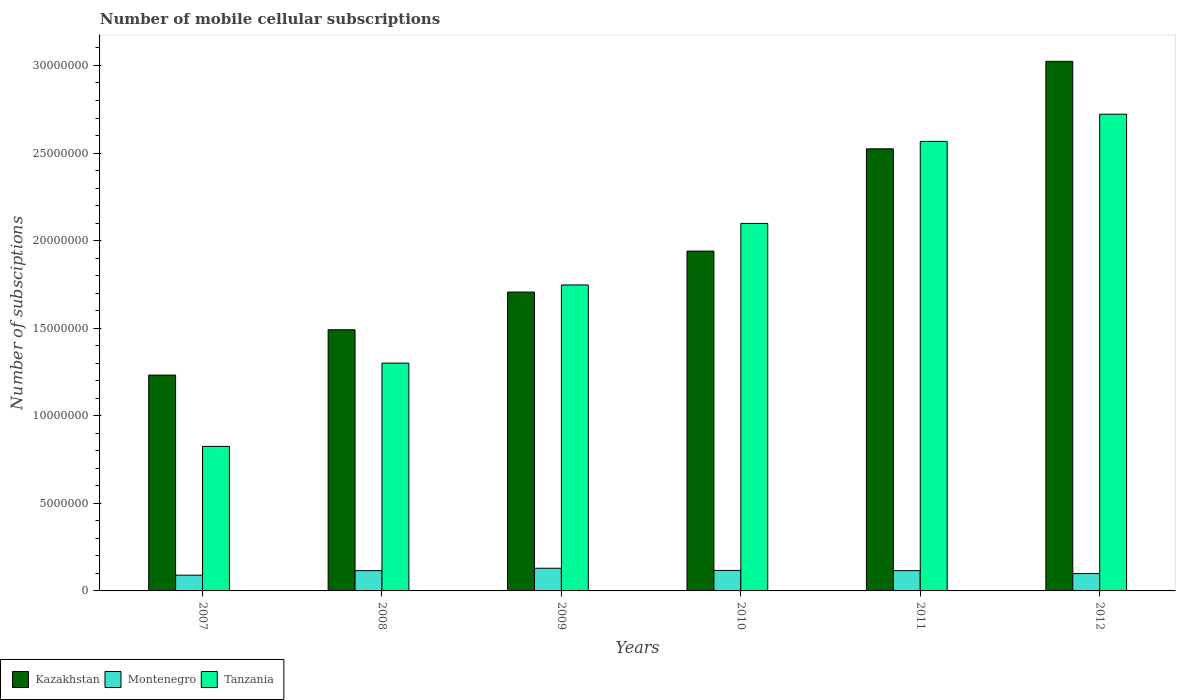How many different coloured bars are there?
Give a very brief answer. 3. How many bars are there on the 1st tick from the left?
Keep it short and to the point. 3. What is the label of the 1st group of bars from the left?
Your answer should be compact. 2007. In how many cases, is the number of bars for a given year not equal to the number of legend labels?
Offer a terse response. 0. What is the number of mobile cellular subscriptions in Tanzania in 2011?
Provide a short and direct response. 2.57e+07. Across all years, what is the maximum number of mobile cellular subscriptions in Tanzania?
Keep it short and to the point. 2.72e+07. Across all years, what is the minimum number of mobile cellular subscriptions in Tanzania?
Your answer should be very brief. 8.25e+06. In which year was the number of mobile cellular subscriptions in Montenegro maximum?
Provide a succinct answer. 2009. In which year was the number of mobile cellular subscriptions in Montenegro minimum?
Give a very brief answer. 2007. What is the total number of mobile cellular subscriptions in Tanzania in the graph?
Offer a very short reply. 1.13e+08. What is the difference between the number of mobile cellular subscriptions in Tanzania in 2010 and that in 2011?
Offer a terse response. -4.68e+06. What is the difference between the number of mobile cellular subscriptions in Montenegro in 2007 and the number of mobile cellular subscriptions in Tanzania in 2010?
Give a very brief answer. -2.01e+07. What is the average number of mobile cellular subscriptions in Kazakhstan per year?
Offer a terse response. 1.99e+07. In the year 2012, what is the difference between the number of mobile cellular subscriptions in Montenegro and number of mobile cellular subscriptions in Tanzania?
Ensure brevity in your answer.  -2.62e+07. In how many years, is the number of mobile cellular subscriptions in Tanzania greater than 18000000?
Offer a terse response. 3. What is the ratio of the number of mobile cellular subscriptions in Tanzania in 2009 to that in 2011?
Your response must be concise. 0.68. Is the number of mobile cellular subscriptions in Kazakhstan in 2008 less than that in 2010?
Offer a terse response. Yes. What is the difference between the highest and the second highest number of mobile cellular subscriptions in Tanzania?
Your answer should be very brief. 1.55e+06. What is the difference between the highest and the lowest number of mobile cellular subscriptions in Tanzania?
Make the answer very short. 1.90e+07. Is the sum of the number of mobile cellular subscriptions in Montenegro in 2011 and 2012 greater than the maximum number of mobile cellular subscriptions in Tanzania across all years?
Provide a short and direct response. No. What does the 3rd bar from the left in 2010 represents?
Offer a terse response. Tanzania. What does the 3rd bar from the right in 2009 represents?
Provide a succinct answer. Kazakhstan. How many bars are there?
Your response must be concise. 18. How many years are there in the graph?
Your response must be concise. 6. What is the difference between two consecutive major ticks on the Y-axis?
Make the answer very short. 5.00e+06. Are the values on the major ticks of Y-axis written in scientific E-notation?
Keep it short and to the point. No. Does the graph contain grids?
Provide a short and direct response. No. How many legend labels are there?
Your answer should be very brief. 3. How are the legend labels stacked?
Provide a succinct answer. Horizontal. What is the title of the graph?
Offer a terse response. Number of mobile cellular subscriptions. Does "Marshall Islands" appear as one of the legend labels in the graph?
Your answer should be compact. No. What is the label or title of the Y-axis?
Your answer should be very brief. Number of subsciptions. What is the Number of subsciptions of Kazakhstan in 2007?
Offer a very short reply. 1.23e+07. What is the Number of subsciptions in Montenegro in 2007?
Offer a very short reply. 9.00e+05. What is the Number of subsciptions in Tanzania in 2007?
Give a very brief answer. 8.25e+06. What is the Number of subsciptions of Kazakhstan in 2008?
Your response must be concise. 1.49e+07. What is the Number of subsciptions of Montenegro in 2008?
Provide a succinct answer. 1.16e+06. What is the Number of subsciptions of Tanzania in 2008?
Your response must be concise. 1.30e+07. What is the Number of subsciptions in Kazakhstan in 2009?
Give a very brief answer. 1.71e+07. What is the Number of subsciptions in Montenegro in 2009?
Offer a terse response. 1.29e+06. What is the Number of subsciptions in Tanzania in 2009?
Make the answer very short. 1.75e+07. What is the Number of subsciptions of Kazakhstan in 2010?
Make the answer very short. 1.94e+07. What is the Number of subsciptions in Montenegro in 2010?
Your response must be concise. 1.17e+06. What is the Number of subsciptions in Tanzania in 2010?
Your answer should be very brief. 2.10e+07. What is the Number of subsciptions of Kazakhstan in 2011?
Offer a terse response. 2.52e+07. What is the Number of subsciptions of Montenegro in 2011?
Your answer should be very brief. 1.16e+06. What is the Number of subsciptions of Tanzania in 2011?
Provide a succinct answer. 2.57e+07. What is the Number of subsciptions of Kazakhstan in 2012?
Your answer should be compact. 3.02e+07. What is the Number of subsciptions of Montenegro in 2012?
Offer a terse response. 9.91e+05. What is the Number of subsciptions in Tanzania in 2012?
Ensure brevity in your answer.  2.72e+07. Across all years, what is the maximum Number of subsciptions of Kazakhstan?
Ensure brevity in your answer.  3.02e+07. Across all years, what is the maximum Number of subsciptions of Montenegro?
Offer a very short reply. 1.29e+06. Across all years, what is the maximum Number of subsciptions of Tanzania?
Provide a short and direct response. 2.72e+07. Across all years, what is the minimum Number of subsciptions of Kazakhstan?
Ensure brevity in your answer.  1.23e+07. Across all years, what is the minimum Number of subsciptions of Tanzania?
Your response must be concise. 8.25e+06. What is the total Number of subsciptions in Kazakhstan in the graph?
Give a very brief answer. 1.19e+08. What is the total Number of subsciptions of Montenegro in the graph?
Provide a short and direct response. 6.67e+06. What is the total Number of subsciptions in Tanzania in the graph?
Give a very brief answer. 1.13e+08. What is the difference between the Number of subsciptions in Kazakhstan in 2007 and that in 2008?
Keep it short and to the point. -2.59e+06. What is the difference between the Number of subsciptions in Montenegro in 2007 and that in 2008?
Your answer should be compact. -2.58e+05. What is the difference between the Number of subsciptions in Tanzania in 2007 and that in 2008?
Keep it short and to the point. -4.75e+06. What is the difference between the Number of subsciptions of Kazakhstan in 2007 and that in 2009?
Provide a short and direct response. -4.74e+06. What is the difference between the Number of subsciptions in Montenegro in 2007 and that in 2009?
Your answer should be compact. -3.94e+05. What is the difference between the Number of subsciptions in Tanzania in 2007 and that in 2009?
Offer a very short reply. -9.22e+06. What is the difference between the Number of subsciptions in Kazakhstan in 2007 and that in 2010?
Your answer should be compact. -7.08e+06. What is the difference between the Number of subsciptions of Montenegro in 2007 and that in 2010?
Give a very brief answer. -2.70e+05. What is the difference between the Number of subsciptions in Tanzania in 2007 and that in 2010?
Your answer should be very brief. -1.27e+07. What is the difference between the Number of subsciptions of Kazakhstan in 2007 and that in 2011?
Provide a succinct answer. -1.29e+07. What is the difference between the Number of subsciptions of Montenegro in 2007 and that in 2011?
Provide a succinct answer. -2.59e+05. What is the difference between the Number of subsciptions in Tanzania in 2007 and that in 2011?
Offer a terse response. -1.74e+07. What is the difference between the Number of subsciptions in Kazakhstan in 2007 and that in 2012?
Give a very brief answer. -1.79e+07. What is the difference between the Number of subsciptions of Montenegro in 2007 and that in 2012?
Your answer should be very brief. -9.09e+04. What is the difference between the Number of subsciptions in Tanzania in 2007 and that in 2012?
Provide a succinct answer. -1.90e+07. What is the difference between the Number of subsciptions in Kazakhstan in 2008 and that in 2009?
Your answer should be compact. -2.15e+06. What is the difference between the Number of subsciptions in Montenegro in 2008 and that in 2009?
Your response must be concise. -1.36e+05. What is the difference between the Number of subsciptions in Tanzania in 2008 and that in 2009?
Offer a terse response. -4.46e+06. What is the difference between the Number of subsciptions of Kazakhstan in 2008 and that in 2010?
Your answer should be compact. -4.49e+06. What is the difference between the Number of subsciptions of Montenegro in 2008 and that in 2010?
Your answer should be compact. -1.20e+04. What is the difference between the Number of subsciptions of Tanzania in 2008 and that in 2010?
Offer a terse response. -7.98e+06. What is the difference between the Number of subsciptions of Kazakhstan in 2008 and that in 2011?
Provide a short and direct response. -1.03e+07. What is the difference between the Number of subsciptions of Montenegro in 2008 and that in 2011?
Ensure brevity in your answer.  -1080. What is the difference between the Number of subsciptions of Tanzania in 2008 and that in 2011?
Offer a very short reply. -1.27e+07. What is the difference between the Number of subsciptions in Kazakhstan in 2008 and that in 2012?
Ensure brevity in your answer.  -1.53e+07. What is the difference between the Number of subsciptions in Montenegro in 2008 and that in 2012?
Your answer should be compact. 1.67e+05. What is the difference between the Number of subsciptions in Tanzania in 2008 and that in 2012?
Ensure brevity in your answer.  -1.42e+07. What is the difference between the Number of subsciptions of Kazakhstan in 2009 and that in 2010?
Your answer should be compact. -2.34e+06. What is the difference between the Number of subsciptions of Montenegro in 2009 and that in 2010?
Provide a succinct answer. 1.24e+05. What is the difference between the Number of subsciptions of Tanzania in 2009 and that in 2010?
Your answer should be compact. -3.51e+06. What is the difference between the Number of subsciptions in Kazakhstan in 2009 and that in 2011?
Your answer should be very brief. -8.18e+06. What is the difference between the Number of subsciptions of Montenegro in 2009 and that in 2011?
Provide a short and direct response. 1.35e+05. What is the difference between the Number of subsciptions of Tanzania in 2009 and that in 2011?
Your response must be concise. -8.20e+06. What is the difference between the Number of subsciptions in Kazakhstan in 2009 and that in 2012?
Your response must be concise. -1.32e+07. What is the difference between the Number of subsciptions in Montenegro in 2009 and that in 2012?
Offer a very short reply. 3.03e+05. What is the difference between the Number of subsciptions of Tanzania in 2009 and that in 2012?
Ensure brevity in your answer.  -9.75e+06. What is the difference between the Number of subsciptions in Kazakhstan in 2010 and that in 2011?
Give a very brief answer. -5.84e+06. What is the difference between the Number of subsciptions in Montenegro in 2010 and that in 2011?
Make the answer very short. 1.09e+04. What is the difference between the Number of subsciptions of Tanzania in 2010 and that in 2011?
Offer a very short reply. -4.68e+06. What is the difference between the Number of subsciptions of Kazakhstan in 2010 and that in 2012?
Keep it short and to the point. -1.08e+07. What is the difference between the Number of subsciptions in Montenegro in 2010 and that in 2012?
Keep it short and to the point. 1.79e+05. What is the difference between the Number of subsciptions in Tanzania in 2010 and that in 2012?
Give a very brief answer. -6.24e+06. What is the difference between the Number of subsciptions in Kazakhstan in 2011 and that in 2012?
Provide a short and direct response. -4.99e+06. What is the difference between the Number of subsciptions in Montenegro in 2011 and that in 2012?
Your response must be concise. 1.68e+05. What is the difference between the Number of subsciptions in Tanzania in 2011 and that in 2012?
Provide a short and direct response. -1.55e+06. What is the difference between the Number of subsciptions of Kazakhstan in 2007 and the Number of subsciptions of Montenegro in 2008?
Keep it short and to the point. 1.12e+07. What is the difference between the Number of subsciptions of Kazakhstan in 2007 and the Number of subsciptions of Tanzania in 2008?
Offer a terse response. -6.84e+05. What is the difference between the Number of subsciptions of Montenegro in 2007 and the Number of subsciptions of Tanzania in 2008?
Offer a very short reply. -1.21e+07. What is the difference between the Number of subsciptions of Kazakhstan in 2007 and the Number of subsciptions of Montenegro in 2009?
Your answer should be compact. 1.10e+07. What is the difference between the Number of subsciptions in Kazakhstan in 2007 and the Number of subsciptions in Tanzania in 2009?
Offer a very short reply. -5.15e+06. What is the difference between the Number of subsciptions in Montenegro in 2007 and the Number of subsciptions in Tanzania in 2009?
Offer a very short reply. -1.66e+07. What is the difference between the Number of subsciptions of Kazakhstan in 2007 and the Number of subsciptions of Montenegro in 2010?
Make the answer very short. 1.12e+07. What is the difference between the Number of subsciptions of Kazakhstan in 2007 and the Number of subsciptions of Tanzania in 2010?
Your answer should be very brief. -8.66e+06. What is the difference between the Number of subsciptions of Montenegro in 2007 and the Number of subsciptions of Tanzania in 2010?
Make the answer very short. -2.01e+07. What is the difference between the Number of subsciptions of Kazakhstan in 2007 and the Number of subsciptions of Montenegro in 2011?
Your response must be concise. 1.12e+07. What is the difference between the Number of subsciptions in Kazakhstan in 2007 and the Number of subsciptions in Tanzania in 2011?
Offer a terse response. -1.33e+07. What is the difference between the Number of subsciptions in Montenegro in 2007 and the Number of subsciptions in Tanzania in 2011?
Your answer should be very brief. -2.48e+07. What is the difference between the Number of subsciptions of Kazakhstan in 2007 and the Number of subsciptions of Montenegro in 2012?
Give a very brief answer. 1.13e+07. What is the difference between the Number of subsciptions of Kazakhstan in 2007 and the Number of subsciptions of Tanzania in 2012?
Your answer should be very brief. -1.49e+07. What is the difference between the Number of subsciptions in Montenegro in 2007 and the Number of subsciptions in Tanzania in 2012?
Ensure brevity in your answer.  -2.63e+07. What is the difference between the Number of subsciptions in Kazakhstan in 2008 and the Number of subsciptions in Montenegro in 2009?
Provide a short and direct response. 1.36e+07. What is the difference between the Number of subsciptions in Kazakhstan in 2008 and the Number of subsciptions in Tanzania in 2009?
Make the answer very short. -2.56e+06. What is the difference between the Number of subsciptions in Montenegro in 2008 and the Number of subsciptions in Tanzania in 2009?
Ensure brevity in your answer.  -1.63e+07. What is the difference between the Number of subsciptions in Kazakhstan in 2008 and the Number of subsciptions in Montenegro in 2010?
Your answer should be compact. 1.37e+07. What is the difference between the Number of subsciptions in Kazakhstan in 2008 and the Number of subsciptions in Tanzania in 2010?
Offer a very short reply. -6.07e+06. What is the difference between the Number of subsciptions of Montenegro in 2008 and the Number of subsciptions of Tanzania in 2010?
Your answer should be compact. -1.98e+07. What is the difference between the Number of subsciptions of Kazakhstan in 2008 and the Number of subsciptions of Montenegro in 2011?
Your answer should be very brief. 1.38e+07. What is the difference between the Number of subsciptions in Kazakhstan in 2008 and the Number of subsciptions in Tanzania in 2011?
Offer a terse response. -1.08e+07. What is the difference between the Number of subsciptions of Montenegro in 2008 and the Number of subsciptions of Tanzania in 2011?
Keep it short and to the point. -2.45e+07. What is the difference between the Number of subsciptions in Kazakhstan in 2008 and the Number of subsciptions in Montenegro in 2012?
Your answer should be compact. 1.39e+07. What is the difference between the Number of subsciptions in Kazakhstan in 2008 and the Number of subsciptions in Tanzania in 2012?
Keep it short and to the point. -1.23e+07. What is the difference between the Number of subsciptions in Montenegro in 2008 and the Number of subsciptions in Tanzania in 2012?
Your response must be concise. -2.61e+07. What is the difference between the Number of subsciptions of Kazakhstan in 2009 and the Number of subsciptions of Montenegro in 2010?
Offer a terse response. 1.59e+07. What is the difference between the Number of subsciptions of Kazakhstan in 2009 and the Number of subsciptions of Tanzania in 2010?
Give a very brief answer. -3.92e+06. What is the difference between the Number of subsciptions of Montenegro in 2009 and the Number of subsciptions of Tanzania in 2010?
Keep it short and to the point. -1.97e+07. What is the difference between the Number of subsciptions of Kazakhstan in 2009 and the Number of subsciptions of Montenegro in 2011?
Give a very brief answer. 1.59e+07. What is the difference between the Number of subsciptions of Kazakhstan in 2009 and the Number of subsciptions of Tanzania in 2011?
Your answer should be compact. -8.60e+06. What is the difference between the Number of subsciptions of Montenegro in 2009 and the Number of subsciptions of Tanzania in 2011?
Your response must be concise. -2.44e+07. What is the difference between the Number of subsciptions of Kazakhstan in 2009 and the Number of subsciptions of Montenegro in 2012?
Offer a terse response. 1.61e+07. What is the difference between the Number of subsciptions in Kazakhstan in 2009 and the Number of subsciptions in Tanzania in 2012?
Your answer should be very brief. -1.02e+07. What is the difference between the Number of subsciptions of Montenegro in 2009 and the Number of subsciptions of Tanzania in 2012?
Ensure brevity in your answer.  -2.59e+07. What is the difference between the Number of subsciptions of Kazakhstan in 2010 and the Number of subsciptions of Montenegro in 2011?
Your answer should be compact. 1.82e+07. What is the difference between the Number of subsciptions in Kazakhstan in 2010 and the Number of subsciptions in Tanzania in 2011?
Offer a very short reply. -6.26e+06. What is the difference between the Number of subsciptions of Montenegro in 2010 and the Number of subsciptions of Tanzania in 2011?
Your answer should be very brief. -2.45e+07. What is the difference between the Number of subsciptions in Kazakhstan in 2010 and the Number of subsciptions in Montenegro in 2012?
Your response must be concise. 1.84e+07. What is the difference between the Number of subsciptions in Kazakhstan in 2010 and the Number of subsciptions in Tanzania in 2012?
Your response must be concise. -7.82e+06. What is the difference between the Number of subsciptions in Montenegro in 2010 and the Number of subsciptions in Tanzania in 2012?
Offer a very short reply. -2.60e+07. What is the difference between the Number of subsciptions of Kazakhstan in 2011 and the Number of subsciptions of Montenegro in 2012?
Offer a terse response. 2.42e+07. What is the difference between the Number of subsciptions of Kazakhstan in 2011 and the Number of subsciptions of Tanzania in 2012?
Offer a terse response. -1.98e+06. What is the difference between the Number of subsciptions in Montenegro in 2011 and the Number of subsciptions in Tanzania in 2012?
Give a very brief answer. -2.61e+07. What is the average Number of subsciptions of Kazakhstan per year?
Provide a succinct answer. 1.99e+07. What is the average Number of subsciptions in Montenegro per year?
Make the answer very short. 1.11e+06. What is the average Number of subsciptions in Tanzania per year?
Give a very brief answer. 1.88e+07. In the year 2007, what is the difference between the Number of subsciptions in Kazakhstan and Number of subsciptions in Montenegro?
Your response must be concise. 1.14e+07. In the year 2007, what is the difference between the Number of subsciptions of Kazakhstan and Number of subsciptions of Tanzania?
Offer a terse response. 4.07e+06. In the year 2007, what is the difference between the Number of subsciptions of Montenegro and Number of subsciptions of Tanzania?
Your answer should be compact. -7.35e+06. In the year 2008, what is the difference between the Number of subsciptions of Kazakhstan and Number of subsciptions of Montenegro?
Offer a terse response. 1.38e+07. In the year 2008, what is the difference between the Number of subsciptions of Kazakhstan and Number of subsciptions of Tanzania?
Your answer should be very brief. 1.90e+06. In the year 2008, what is the difference between the Number of subsciptions in Montenegro and Number of subsciptions in Tanzania?
Your response must be concise. -1.18e+07. In the year 2009, what is the difference between the Number of subsciptions in Kazakhstan and Number of subsciptions in Montenegro?
Make the answer very short. 1.58e+07. In the year 2009, what is the difference between the Number of subsciptions in Kazakhstan and Number of subsciptions in Tanzania?
Your answer should be compact. -4.06e+05. In the year 2009, what is the difference between the Number of subsciptions in Montenegro and Number of subsciptions in Tanzania?
Your answer should be compact. -1.62e+07. In the year 2010, what is the difference between the Number of subsciptions of Kazakhstan and Number of subsciptions of Montenegro?
Provide a short and direct response. 1.82e+07. In the year 2010, what is the difference between the Number of subsciptions in Kazakhstan and Number of subsciptions in Tanzania?
Provide a short and direct response. -1.58e+06. In the year 2010, what is the difference between the Number of subsciptions of Montenegro and Number of subsciptions of Tanzania?
Your response must be concise. -1.98e+07. In the year 2011, what is the difference between the Number of subsciptions of Kazakhstan and Number of subsciptions of Montenegro?
Ensure brevity in your answer.  2.41e+07. In the year 2011, what is the difference between the Number of subsciptions of Kazakhstan and Number of subsciptions of Tanzania?
Keep it short and to the point. -4.26e+05. In the year 2011, what is the difference between the Number of subsciptions in Montenegro and Number of subsciptions in Tanzania?
Offer a terse response. -2.45e+07. In the year 2012, what is the difference between the Number of subsciptions in Kazakhstan and Number of subsciptions in Montenegro?
Offer a terse response. 2.92e+07. In the year 2012, what is the difference between the Number of subsciptions in Kazakhstan and Number of subsciptions in Tanzania?
Offer a terse response. 3.02e+06. In the year 2012, what is the difference between the Number of subsciptions of Montenegro and Number of subsciptions of Tanzania?
Offer a very short reply. -2.62e+07. What is the ratio of the Number of subsciptions in Kazakhstan in 2007 to that in 2008?
Your answer should be compact. 0.83. What is the ratio of the Number of subsciptions in Montenegro in 2007 to that in 2008?
Ensure brevity in your answer.  0.78. What is the ratio of the Number of subsciptions of Tanzania in 2007 to that in 2008?
Your response must be concise. 0.63. What is the ratio of the Number of subsciptions in Kazakhstan in 2007 to that in 2009?
Your response must be concise. 0.72. What is the ratio of the Number of subsciptions in Montenegro in 2007 to that in 2009?
Provide a succinct answer. 0.7. What is the ratio of the Number of subsciptions of Tanzania in 2007 to that in 2009?
Your answer should be compact. 0.47. What is the ratio of the Number of subsciptions of Kazakhstan in 2007 to that in 2010?
Your answer should be very brief. 0.64. What is the ratio of the Number of subsciptions in Montenegro in 2007 to that in 2010?
Your answer should be compact. 0.77. What is the ratio of the Number of subsciptions in Tanzania in 2007 to that in 2010?
Offer a terse response. 0.39. What is the ratio of the Number of subsciptions of Kazakhstan in 2007 to that in 2011?
Make the answer very short. 0.49. What is the ratio of the Number of subsciptions in Montenegro in 2007 to that in 2011?
Offer a very short reply. 0.78. What is the ratio of the Number of subsciptions in Tanzania in 2007 to that in 2011?
Offer a very short reply. 0.32. What is the ratio of the Number of subsciptions in Kazakhstan in 2007 to that in 2012?
Offer a terse response. 0.41. What is the ratio of the Number of subsciptions of Montenegro in 2007 to that in 2012?
Ensure brevity in your answer.  0.91. What is the ratio of the Number of subsciptions of Tanzania in 2007 to that in 2012?
Ensure brevity in your answer.  0.3. What is the ratio of the Number of subsciptions in Kazakhstan in 2008 to that in 2009?
Ensure brevity in your answer.  0.87. What is the ratio of the Number of subsciptions in Montenegro in 2008 to that in 2009?
Your answer should be very brief. 0.89. What is the ratio of the Number of subsciptions in Tanzania in 2008 to that in 2009?
Your answer should be very brief. 0.74. What is the ratio of the Number of subsciptions in Kazakhstan in 2008 to that in 2010?
Offer a very short reply. 0.77. What is the ratio of the Number of subsciptions of Tanzania in 2008 to that in 2010?
Your answer should be very brief. 0.62. What is the ratio of the Number of subsciptions in Kazakhstan in 2008 to that in 2011?
Keep it short and to the point. 0.59. What is the ratio of the Number of subsciptions of Tanzania in 2008 to that in 2011?
Give a very brief answer. 0.51. What is the ratio of the Number of subsciptions of Kazakhstan in 2008 to that in 2012?
Keep it short and to the point. 0.49. What is the ratio of the Number of subsciptions of Montenegro in 2008 to that in 2012?
Provide a short and direct response. 1.17. What is the ratio of the Number of subsciptions of Tanzania in 2008 to that in 2012?
Offer a terse response. 0.48. What is the ratio of the Number of subsciptions in Kazakhstan in 2009 to that in 2010?
Ensure brevity in your answer.  0.88. What is the ratio of the Number of subsciptions of Montenegro in 2009 to that in 2010?
Offer a very short reply. 1.11. What is the ratio of the Number of subsciptions of Tanzania in 2009 to that in 2010?
Your answer should be compact. 0.83. What is the ratio of the Number of subsciptions of Kazakhstan in 2009 to that in 2011?
Ensure brevity in your answer.  0.68. What is the ratio of the Number of subsciptions of Montenegro in 2009 to that in 2011?
Your answer should be very brief. 1.12. What is the ratio of the Number of subsciptions in Tanzania in 2009 to that in 2011?
Keep it short and to the point. 0.68. What is the ratio of the Number of subsciptions in Kazakhstan in 2009 to that in 2012?
Ensure brevity in your answer.  0.56. What is the ratio of the Number of subsciptions in Montenegro in 2009 to that in 2012?
Your response must be concise. 1.31. What is the ratio of the Number of subsciptions of Tanzania in 2009 to that in 2012?
Give a very brief answer. 0.64. What is the ratio of the Number of subsciptions of Kazakhstan in 2010 to that in 2011?
Offer a terse response. 0.77. What is the ratio of the Number of subsciptions in Montenegro in 2010 to that in 2011?
Your answer should be very brief. 1.01. What is the ratio of the Number of subsciptions of Tanzania in 2010 to that in 2011?
Your answer should be compact. 0.82. What is the ratio of the Number of subsciptions in Kazakhstan in 2010 to that in 2012?
Keep it short and to the point. 0.64. What is the ratio of the Number of subsciptions of Montenegro in 2010 to that in 2012?
Your answer should be very brief. 1.18. What is the ratio of the Number of subsciptions of Tanzania in 2010 to that in 2012?
Offer a terse response. 0.77. What is the ratio of the Number of subsciptions in Kazakhstan in 2011 to that in 2012?
Provide a short and direct response. 0.83. What is the ratio of the Number of subsciptions in Montenegro in 2011 to that in 2012?
Your answer should be compact. 1.17. What is the ratio of the Number of subsciptions in Tanzania in 2011 to that in 2012?
Your answer should be compact. 0.94. What is the difference between the highest and the second highest Number of subsciptions of Kazakhstan?
Provide a short and direct response. 4.99e+06. What is the difference between the highest and the second highest Number of subsciptions in Montenegro?
Provide a short and direct response. 1.24e+05. What is the difference between the highest and the second highest Number of subsciptions of Tanzania?
Offer a very short reply. 1.55e+06. What is the difference between the highest and the lowest Number of subsciptions of Kazakhstan?
Offer a very short reply. 1.79e+07. What is the difference between the highest and the lowest Number of subsciptions in Montenegro?
Provide a succinct answer. 3.94e+05. What is the difference between the highest and the lowest Number of subsciptions of Tanzania?
Your answer should be very brief. 1.90e+07. 